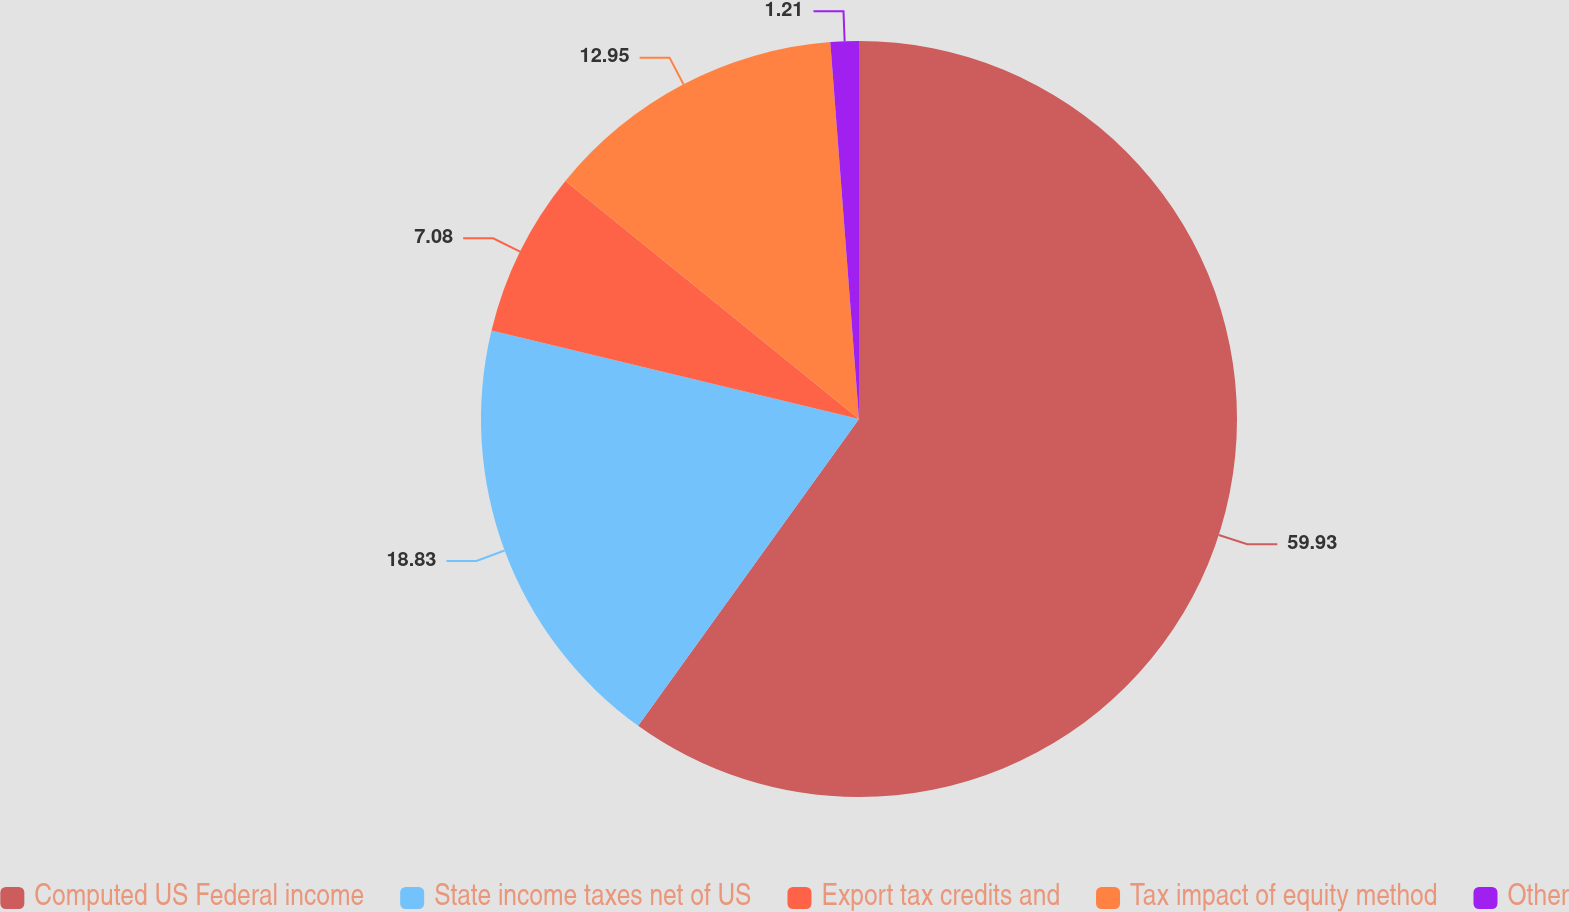Convert chart to OTSL. <chart><loc_0><loc_0><loc_500><loc_500><pie_chart><fcel>Computed US Federal income<fcel>State income taxes net of US<fcel>Export tax credits and<fcel>Tax impact of equity method<fcel>Other<nl><fcel>59.93%<fcel>18.83%<fcel>7.08%<fcel>12.95%<fcel>1.21%<nl></chart> 